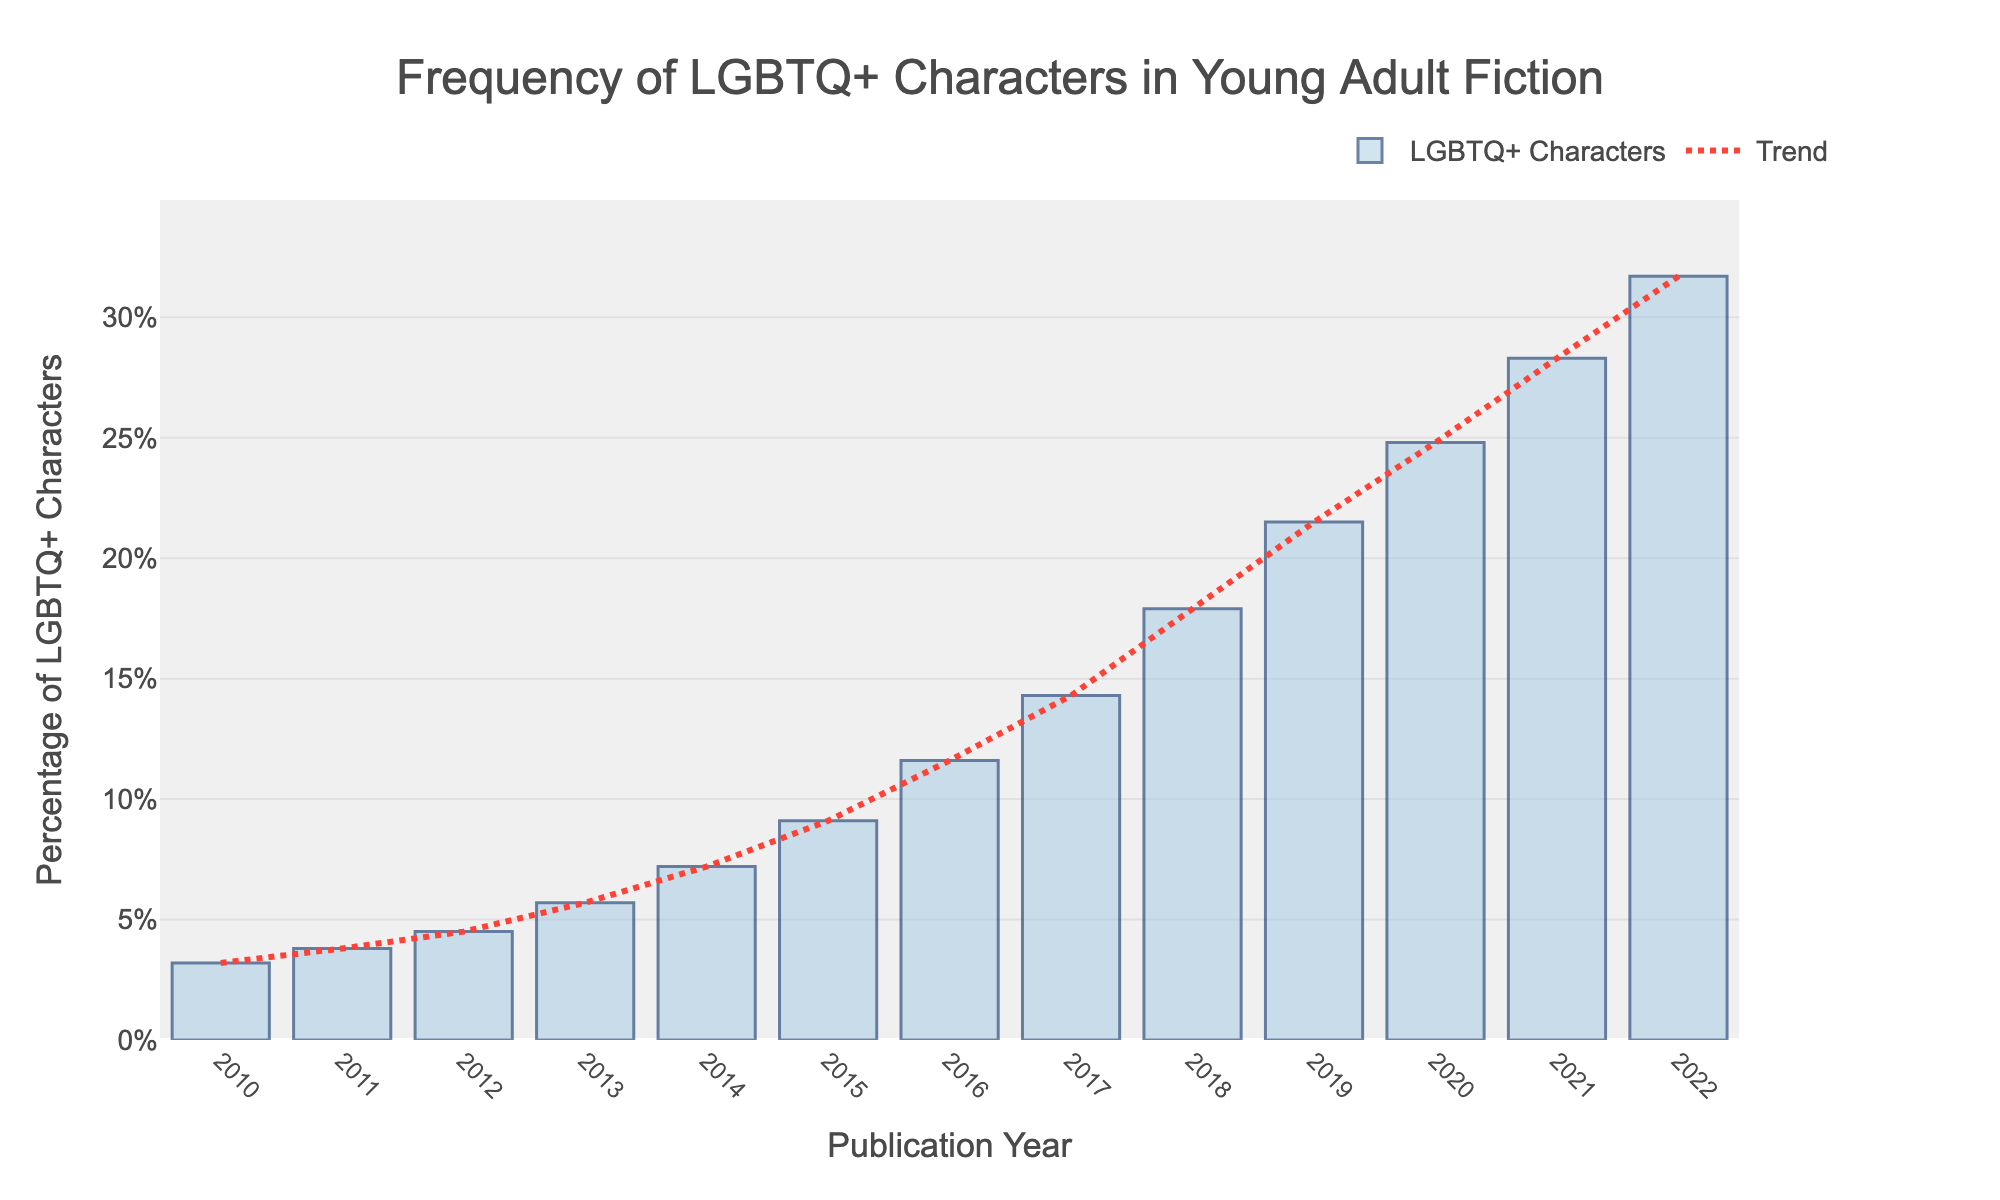How has the percentage of LGBTQ+ characters changed from 2010 to 2011? To find the change, subtract the percentage of 2010 from the percentage of 2011. The values are 3.8% for 2011 and 3.2% for 2010. So, the change is 3.8% - 3.2% = 0.6%.
Answer: 0.6% In which year did the percentage of LGBTQ+ characters exceed 20%? To find this, look at the bars and spot the year where the percentage first exceeds 20%. It surpasses 20% in 2019 with 21.5%.
Answer: 2019 What is the average percentage of LGBTQ+ characters between 2015 and 2019? Add the percentages from 2015 to 2019 and divide by the number of years (5). The values are 9.1%, 11.6%, 14.3%, 17.9%, and 21.5%. The sum is 74.4%, and the average is 74.4% / 5 = 14.88%.
Answer: 14.88% Between 2020 and 2022, what is the total increase in the percentage of LGBTQ+ characters? Subtract the percentage of 2020 from the percentage of 2022. The values are 31.7% for 2022 and 24.8% for 2020. So, the increase is 31.7% - 24.8% = 6.9%.
Answer: 6.9% By how much did the percentage of LGBTQ+ characters increase from the lowest to the highest value in the data? The lowest percentage is in 2010 (3.2%), and the highest is in 2022 (31.7%). The increase is 31.7% - 3.2% = 28.5%.
Answer: 28.5% Which year had the fastest growth in the percentage of LGBTQ+ characters compared to the previous year? Observe the bars to find the year with the highest absolute yearly increase. From 2019 (21.5%) to 2020 (24.8%) shows an increase of 3.3%, the largest annual growth.
Answer: 2019 to 2020 How does the height of the bar for 2017 compare to that of 2012? By visually comparing the bar heights, the percentage for 2017 (14.3%) is more than three times the percentage for 2012 (4.5%).
Answer: 2017 is more than three times 2012 What trend is observed in the frequency of LGBTQ+ characters from 2010 to 2022? The trend line shows a consistent increase over the years, indicating a steady rise in the representation of LGBTQ+ characters in young adult fiction.
Answer: Increasing trend 